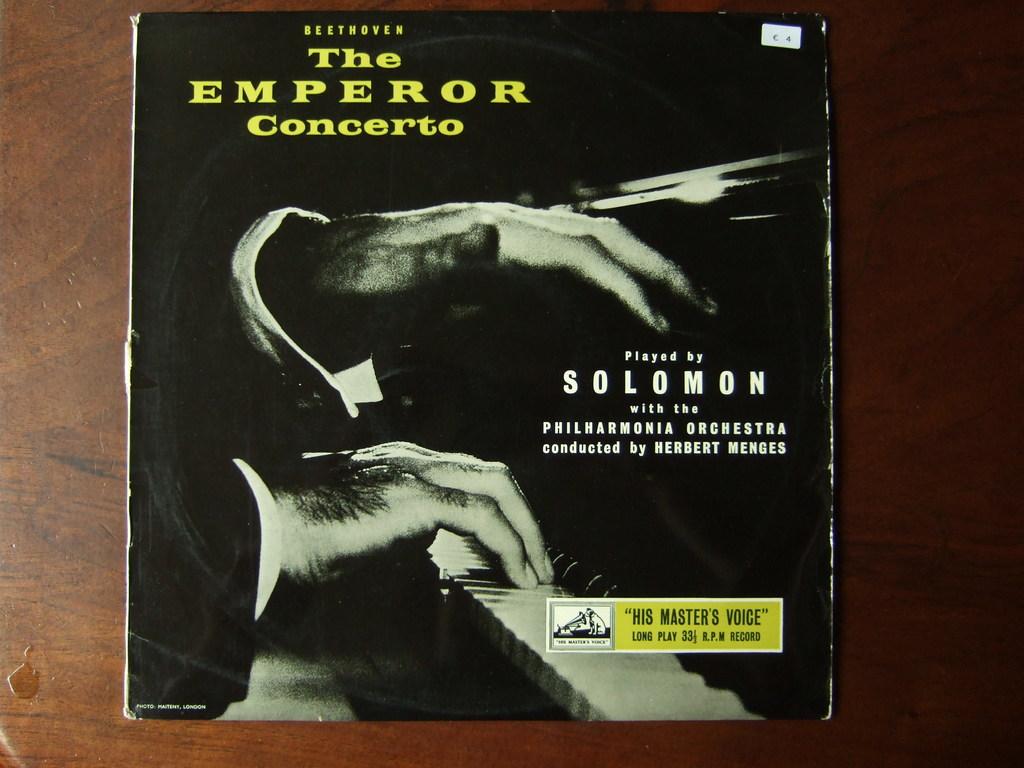What is the title of this?
Offer a very short reply. The emperor concerto. Who is the musician of the record?
Your answer should be very brief. Solomon. 